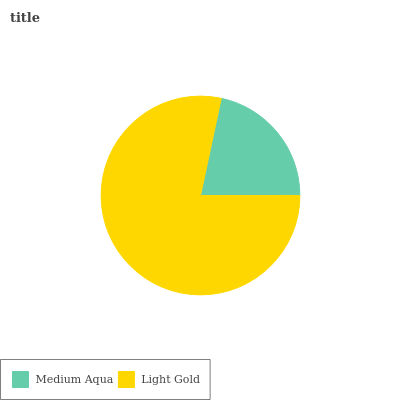Is Medium Aqua the minimum?
Answer yes or no. Yes. Is Light Gold the maximum?
Answer yes or no. Yes. Is Light Gold the minimum?
Answer yes or no. No. Is Light Gold greater than Medium Aqua?
Answer yes or no. Yes. Is Medium Aqua less than Light Gold?
Answer yes or no. Yes. Is Medium Aqua greater than Light Gold?
Answer yes or no. No. Is Light Gold less than Medium Aqua?
Answer yes or no. No. Is Light Gold the high median?
Answer yes or no. Yes. Is Medium Aqua the low median?
Answer yes or no. Yes. Is Medium Aqua the high median?
Answer yes or no. No. Is Light Gold the low median?
Answer yes or no. No. 